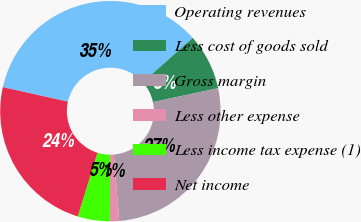Convert chart to OTSL. <chart><loc_0><loc_0><loc_500><loc_500><pie_chart><fcel>Operating revenues<fcel>Less cost of goods sold<fcel>Gross margin<fcel>Less other expense<fcel>Less income tax expense (1)<fcel>Net income<nl><fcel>34.93%<fcel>8.23%<fcel>27.07%<fcel>1.35%<fcel>4.71%<fcel>23.71%<nl></chart> 